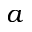<formula> <loc_0><loc_0><loc_500><loc_500>a</formula> 